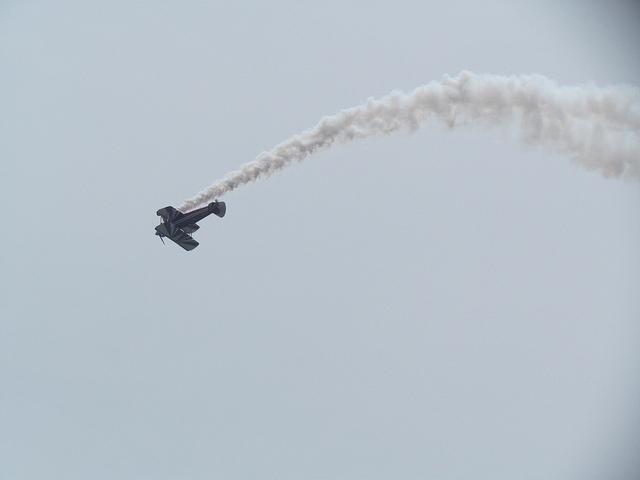Where is the smoke coming from?
Answer briefly. Plane. What is the big black object in the center of the photo?
Write a very short answer. Airplane. What type of plane is this?
Quick response, please. Biplane. Would this be seen as part of fashion design?
Concise answer only. No. What color is the plane?
Be succinct. White. 